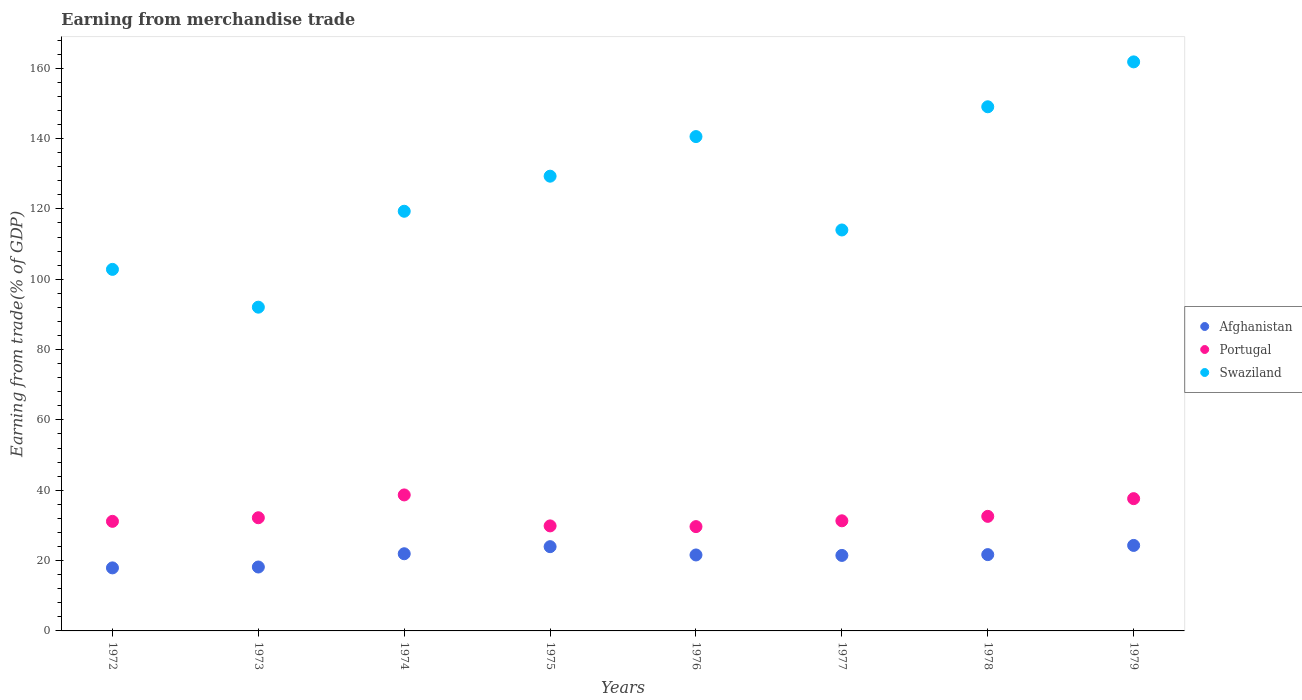What is the earnings from trade in Swaziland in 1978?
Your answer should be compact. 149.03. Across all years, what is the maximum earnings from trade in Swaziland?
Provide a short and direct response. 161.8. Across all years, what is the minimum earnings from trade in Afghanistan?
Provide a succinct answer. 17.92. In which year was the earnings from trade in Portugal maximum?
Ensure brevity in your answer.  1974. In which year was the earnings from trade in Afghanistan minimum?
Keep it short and to the point. 1972. What is the total earnings from trade in Afghanistan in the graph?
Your response must be concise. 171.07. What is the difference between the earnings from trade in Afghanistan in 1978 and that in 1979?
Ensure brevity in your answer.  -2.61. What is the difference between the earnings from trade in Swaziland in 1979 and the earnings from trade in Portugal in 1974?
Offer a terse response. 123.13. What is the average earnings from trade in Portugal per year?
Keep it short and to the point. 32.88. In the year 1979, what is the difference between the earnings from trade in Swaziland and earnings from trade in Afghanistan?
Your answer should be very brief. 137.49. In how many years, is the earnings from trade in Portugal greater than 16 %?
Provide a short and direct response. 8. What is the ratio of the earnings from trade in Portugal in 1973 to that in 1979?
Give a very brief answer. 0.86. Is the difference between the earnings from trade in Swaziland in 1973 and 1977 greater than the difference between the earnings from trade in Afghanistan in 1973 and 1977?
Keep it short and to the point. No. What is the difference between the highest and the second highest earnings from trade in Portugal?
Offer a terse response. 1.06. What is the difference between the highest and the lowest earnings from trade in Portugal?
Provide a succinct answer. 9.01. In how many years, is the earnings from trade in Swaziland greater than the average earnings from trade in Swaziland taken over all years?
Provide a short and direct response. 4. Is it the case that in every year, the sum of the earnings from trade in Portugal and earnings from trade in Swaziland  is greater than the earnings from trade in Afghanistan?
Make the answer very short. Yes. Is the earnings from trade in Afghanistan strictly greater than the earnings from trade in Swaziland over the years?
Your response must be concise. No. Is the earnings from trade in Portugal strictly less than the earnings from trade in Afghanistan over the years?
Make the answer very short. No. How many dotlines are there?
Your response must be concise. 3. How many years are there in the graph?
Provide a succinct answer. 8. What is the difference between two consecutive major ticks on the Y-axis?
Offer a terse response. 20. Are the values on the major ticks of Y-axis written in scientific E-notation?
Keep it short and to the point. No. Does the graph contain any zero values?
Offer a terse response. No. Does the graph contain grids?
Make the answer very short. No. Where does the legend appear in the graph?
Give a very brief answer. Center right. How many legend labels are there?
Keep it short and to the point. 3. What is the title of the graph?
Keep it short and to the point. Earning from merchandise trade. What is the label or title of the X-axis?
Provide a short and direct response. Years. What is the label or title of the Y-axis?
Your answer should be compact. Earning from trade(% of GDP). What is the Earning from trade(% of GDP) in Afghanistan in 1972?
Your answer should be very brief. 17.92. What is the Earning from trade(% of GDP) of Portugal in 1972?
Provide a short and direct response. 31.16. What is the Earning from trade(% of GDP) in Swaziland in 1972?
Give a very brief answer. 102.8. What is the Earning from trade(% of GDP) of Afghanistan in 1973?
Offer a very short reply. 18.17. What is the Earning from trade(% of GDP) of Portugal in 1973?
Keep it short and to the point. 32.18. What is the Earning from trade(% of GDP) of Swaziland in 1973?
Keep it short and to the point. 92.05. What is the Earning from trade(% of GDP) of Afghanistan in 1974?
Make the answer very short. 21.94. What is the Earning from trade(% of GDP) in Portugal in 1974?
Your response must be concise. 38.67. What is the Earning from trade(% of GDP) of Swaziland in 1974?
Provide a succinct answer. 119.33. What is the Earning from trade(% of GDP) of Afghanistan in 1975?
Keep it short and to the point. 23.96. What is the Earning from trade(% of GDP) in Portugal in 1975?
Your answer should be very brief. 29.86. What is the Earning from trade(% of GDP) in Swaziland in 1975?
Provide a short and direct response. 129.3. What is the Earning from trade(% of GDP) in Afghanistan in 1976?
Your response must be concise. 21.6. What is the Earning from trade(% of GDP) in Portugal in 1976?
Offer a very short reply. 29.66. What is the Earning from trade(% of GDP) in Swaziland in 1976?
Your response must be concise. 140.56. What is the Earning from trade(% of GDP) of Afghanistan in 1977?
Provide a short and direct response. 21.47. What is the Earning from trade(% of GDP) of Portugal in 1977?
Your response must be concise. 31.31. What is the Earning from trade(% of GDP) in Swaziland in 1977?
Ensure brevity in your answer.  114.01. What is the Earning from trade(% of GDP) of Afghanistan in 1978?
Offer a terse response. 21.7. What is the Earning from trade(% of GDP) of Portugal in 1978?
Offer a terse response. 32.57. What is the Earning from trade(% of GDP) of Swaziland in 1978?
Your answer should be compact. 149.03. What is the Earning from trade(% of GDP) in Afghanistan in 1979?
Give a very brief answer. 24.31. What is the Earning from trade(% of GDP) in Portugal in 1979?
Keep it short and to the point. 37.61. What is the Earning from trade(% of GDP) of Swaziland in 1979?
Offer a very short reply. 161.8. Across all years, what is the maximum Earning from trade(% of GDP) in Afghanistan?
Your answer should be compact. 24.31. Across all years, what is the maximum Earning from trade(% of GDP) of Portugal?
Your answer should be very brief. 38.67. Across all years, what is the maximum Earning from trade(% of GDP) in Swaziland?
Provide a succinct answer. 161.8. Across all years, what is the minimum Earning from trade(% of GDP) in Afghanistan?
Keep it short and to the point. 17.92. Across all years, what is the minimum Earning from trade(% of GDP) of Portugal?
Provide a short and direct response. 29.66. Across all years, what is the minimum Earning from trade(% of GDP) in Swaziland?
Ensure brevity in your answer.  92.05. What is the total Earning from trade(% of GDP) in Afghanistan in the graph?
Make the answer very short. 171.07. What is the total Earning from trade(% of GDP) in Portugal in the graph?
Offer a terse response. 263.02. What is the total Earning from trade(% of GDP) in Swaziland in the graph?
Provide a succinct answer. 1008.89. What is the difference between the Earning from trade(% of GDP) of Afghanistan in 1972 and that in 1973?
Keep it short and to the point. -0.25. What is the difference between the Earning from trade(% of GDP) of Portugal in 1972 and that in 1973?
Provide a short and direct response. -1.02. What is the difference between the Earning from trade(% of GDP) of Swaziland in 1972 and that in 1973?
Provide a short and direct response. 10.75. What is the difference between the Earning from trade(% of GDP) of Afghanistan in 1972 and that in 1974?
Ensure brevity in your answer.  -4.02. What is the difference between the Earning from trade(% of GDP) in Portugal in 1972 and that in 1974?
Keep it short and to the point. -7.51. What is the difference between the Earning from trade(% of GDP) in Swaziland in 1972 and that in 1974?
Your answer should be compact. -16.52. What is the difference between the Earning from trade(% of GDP) of Afghanistan in 1972 and that in 1975?
Ensure brevity in your answer.  -6.03. What is the difference between the Earning from trade(% of GDP) in Portugal in 1972 and that in 1975?
Offer a very short reply. 1.3. What is the difference between the Earning from trade(% of GDP) in Swaziland in 1972 and that in 1975?
Keep it short and to the point. -26.5. What is the difference between the Earning from trade(% of GDP) in Afghanistan in 1972 and that in 1976?
Give a very brief answer. -3.68. What is the difference between the Earning from trade(% of GDP) in Portugal in 1972 and that in 1976?
Offer a very short reply. 1.5. What is the difference between the Earning from trade(% of GDP) in Swaziland in 1972 and that in 1976?
Ensure brevity in your answer.  -37.76. What is the difference between the Earning from trade(% of GDP) of Afghanistan in 1972 and that in 1977?
Make the answer very short. -3.54. What is the difference between the Earning from trade(% of GDP) of Portugal in 1972 and that in 1977?
Your answer should be very brief. -0.15. What is the difference between the Earning from trade(% of GDP) of Swaziland in 1972 and that in 1977?
Your answer should be compact. -11.2. What is the difference between the Earning from trade(% of GDP) of Afghanistan in 1972 and that in 1978?
Your response must be concise. -3.77. What is the difference between the Earning from trade(% of GDP) of Portugal in 1972 and that in 1978?
Ensure brevity in your answer.  -1.42. What is the difference between the Earning from trade(% of GDP) of Swaziland in 1972 and that in 1978?
Your answer should be very brief. -46.23. What is the difference between the Earning from trade(% of GDP) in Afghanistan in 1972 and that in 1979?
Your response must be concise. -6.39. What is the difference between the Earning from trade(% of GDP) of Portugal in 1972 and that in 1979?
Provide a short and direct response. -6.45. What is the difference between the Earning from trade(% of GDP) in Swaziland in 1972 and that in 1979?
Provide a short and direct response. -59. What is the difference between the Earning from trade(% of GDP) in Afghanistan in 1973 and that in 1974?
Your response must be concise. -3.77. What is the difference between the Earning from trade(% of GDP) in Portugal in 1973 and that in 1974?
Provide a short and direct response. -6.49. What is the difference between the Earning from trade(% of GDP) of Swaziland in 1973 and that in 1974?
Provide a short and direct response. -27.27. What is the difference between the Earning from trade(% of GDP) in Afghanistan in 1973 and that in 1975?
Keep it short and to the point. -5.78. What is the difference between the Earning from trade(% of GDP) of Portugal in 1973 and that in 1975?
Your response must be concise. 2.32. What is the difference between the Earning from trade(% of GDP) in Swaziland in 1973 and that in 1975?
Your answer should be compact. -37.25. What is the difference between the Earning from trade(% of GDP) in Afghanistan in 1973 and that in 1976?
Offer a terse response. -3.43. What is the difference between the Earning from trade(% of GDP) in Portugal in 1973 and that in 1976?
Provide a succinct answer. 2.52. What is the difference between the Earning from trade(% of GDP) of Swaziland in 1973 and that in 1976?
Provide a short and direct response. -48.51. What is the difference between the Earning from trade(% of GDP) in Afghanistan in 1973 and that in 1977?
Provide a succinct answer. -3.29. What is the difference between the Earning from trade(% of GDP) of Portugal in 1973 and that in 1977?
Your response must be concise. 0.87. What is the difference between the Earning from trade(% of GDP) in Swaziland in 1973 and that in 1977?
Offer a very short reply. -21.95. What is the difference between the Earning from trade(% of GDP) of Afghanistan in 1973 and that in 1978?
Provide a short and direct response. -3.52. What is the difference between the Earning from trade(% of GDP) of Portugal in 1973 and that in 1978?
Your answer should be compact. -0.4. What is the difference between the Earning from trade(% of GDP) of Swaziland in 1973 and that in 1978?
Ensure brevity in your answer.  -56.98. What is the difference between the Earning from trade(% of GDP) in Afghanistan in 1973 and that in 1979?
Your response must be concise. -6.14. What is the difference between the Earning from trade(% of GDP) of Portugal in 1973 and that in 1979?
Your answer should be very brief. -5.43. What is the difference between the Earning from trade(% of GDP) in Swaziland in 1973 and that in 1979?
Provide a short and direct response. -69.75. What is the difference between the Earning from trade(% of GDP) of Afghanistan in 1974 and that in 1975?
Make the answer very short. -2.01. What is the difference between the Earning from trade(% of GDP) of Portugal in 1974 and that in 1975?
Keep it short and to the point. 8.81. What is the difference between the Earning from trade(% of GDP) of Swaziland in 1974 and that in 1975?
Offer a terse response. -9.97. What is the difference between the Earning from trade(% of GDP) in Afghanistan in 1974 and that in 1976?
Ensure brevity in your answer.  0.34. What is the difference between the Earning from trade(% of GDP) in Portugal in 1974 and that in 1976?
Make the answer very short. 9.01. What is the difference between the Earning from trade(% of GDP) of Swaziland in 1974 and that in 1976?
Your answer should be compact. -21.23. What is the difference between the Earning from trade(% of GDP) of Afghanistan in 1974 and that in 1977?
Provide a succinct answer. 0.48. What is the difference between the Earning from trade(% of GDP) of Portugal in 1974 and that in 1977?
Your response must be concise. 7.36. What is the difference between the Earning from trade(% of GDP) in Swaziland in 1974 and that in 1977?
Provide a succinct answer. 5.32. What is the difference between the Earning from trade(% of GDP) of Afghanistan in 1974 and that in 1978?
Give a very brief answer. 0.25. What is the difference between the Earning from trade(% of GDP) in Portugal in 1974 and that in 1978?
Offer a very short reply. 6.09. What is the difference between the Earning from trade(% of GDP) in Swaziland in 1974 and that in 1978?
Ensure brevity in your answer.  -29.71. What is the difference between the Earning from trade(% of GDP) of Afghanistan in 1974 and that in 1979?
Give a very brief answer. -2.37. What is the difference between the Earning from trade(% of GDP) of Portugal in 1974 and that in 1979?
Give a very brief answer. 1.06. What is the difference between the Earning from trade(% of GDP) of Swaziland in 1974 and that in 1979?
Your answer should be very brief. -42.48. What is the difference between the Earning from trade(% of GDP) in Afghanistan in 1975 and that in 1976?
Your response must be concise. 2.36. What is the difference between the Earning from trade(% of GDP) of Portugal in 1975 and that in 1976?
Keep it short and to the point. 0.2. What is the difference between the Earning from trade(% of GDP) in Swaziland in 1975 and that in 1976?
Provide a short and direct response. -11.26. What is the difference between the Earning from trade(% of GDP) in Afghanistan in 1975 and that in 1977?
Offer a terse response. 2.49. What is the difference between the Earning from trade(% of GDP) in Portugal in 1975 and that in 1977?
Make the answer very short. -1.45. What is the difference between the Earning from trade(% of GDP) of Swaziland in 1975 and that in 1977?
Offer a terse response. 15.3. What is the difference between the Earning from trade(% of GDP) of Afghanistan in 1975 and that in 1978?
Your answer should be compact. 2.26. What is the difference between the Earning from trade(% of GDP) of Portugal in 1975 and that in 1978?
Your response must be concise. -2.71. What is the difference between the Earning from trade(% of GDP) of Swaziland in 1975 and that in 1978?
Provide a short and direct response. -19.73. What is the difference between the Earning from trade(% of GDP) in Afghanistan in 1975 and that in 1979?
Make the answer very short. -0.35. What is the difference between the Earning from trade(% of GDP) of Portugal in 1975 and that in 1979?
Offer a terse response. -7.75. What is the difference between the Earning from trade(% of GDP) in Swaziland in 1975 and that in 1979?
Your response must be concise. -32.5. What is the difference between the Earning from trade(% of GDP) in Afghanistan in 1976 and that in 1977?
Offer a very short reply. 0.13. What is the difference between the Earning from trade(% of GDP) of Portugal in 1976 and that in 1977?
Your answer should be compact. -1.65. What is the difference between the Earning from trade(% of GDP) of Swaziland in 1976 and that in 1977?
Provide a short and direct response. 26.56. What is the difference between the Earning from trade(% of GDP) in Afghanistan in 1976 and that in 1978?
Your answer should be very brief. -0.1. What is the difference between the Earning from trade(% of GDP) in Portugal in 1976 and that in 1978?
Provide a short and direct response. -2.92. What is the difference between the Earning from trade(% of GDP) in Swaziland in 1976 and that in 1978?
Provide a short and direct response. -8.47. What is the difference between the Earning from trade(% of GDP) in Afghanistan in 1976 and that in 1979?
Make the answer very short. -2.71. What is the difference between the Earning from trade(% of GDP) in Portugal in 1976 and that in 1979?
Provide a short and direct response. -7.95. What is the difference between the Earning from trade(% of GDP) in Swaziland in 1976 and that in 1979?
Give a very brief answer. -21.24. What is the difference between the Earning from trade(% of GDP) of Afghanistan in 1977 and that in 1978?
Ensure brevity in your answer.  -0.23. What is the difference between the Earning from trade(% of GDP) in Portugal in 1977 and that in 1978?
Provide a short and direct response. -1.26. What is the difference between the Earning from trade(% of GDP) in Swaziland in 1977 and that in 1978?
Provide a short and direct response. -35.03. What is the difference between the Earning from trade(% of GDP) in Afghanistan in 1977 and that in 1979?
Your answer should be compact. -2.84. What is the difference between the Earning from trade(% of GDP) of Portugal in 1977 and that in 1979?
Your answer should be compact. -6.3. What is the difference between the Earning from trade(% of GDP) in Swaziland in 1977 and that in 1979?
Your answer should be compact. -47.8. What is the difference between the Earning from trade(% of GDP) in Afghanistan in 1978 and that in 1979?
Offer a terse response. -2.61. What is the difference between the Earning from trade(% of GDP) of Portugal in 1978 and that in 1979?
Your response must be concise. -5.04. What is the difference between the Earning from trade(% of GDP) in Swaziland in 1978 and that in 1979?
Provide a short and direct response. -12.77. What is the difference between the Earning from trade(% of GDP) in Afghanistan in 1972 and the Earning from trade(% of GDP) in Portugal in 1973?
Your response must be concise. -14.25. What is the difference between the Earning from trade(% of GDP) of Afghanistan in 1972 and the Earning from trade(% of GDP) of Swaziland in 1973?
Make the answer very short. -74.13. What is the difference between the Earning from trade(% of GDP) of Portugal in 1972 and the Earning from trade(% of GDP) of Swaziland in 1973?
Offer a very short reply. -60.9. What is the difference between the Earning from trade(% of GDP) in Afghanistan in 1972 and the Earning from trade(% of GDP) in Portugal in 1974?
Ensure brevity in your answer.  -20.74. What is the difference between the Earning from trade(% of GDP) in Afghanistan in 1972 and the Earning from trade(% of GDP) in Swaziland in 1974?
Provide a succinct answer. -101.4. What is the difference between the Earning from trade(% of GDP) in Portugal in 1972 and the Earning from trade(% of GDP) in Swaziland in 1974?
Give a very brief answer. -88.17. What is the difference between the Earning from trade(% of GDP) in Afghanistan in 1972 and the Earning from trade(% of GDP) in Portugal in 1975?
Provide a short and direct response. -11.94. What is the difference between the Earning from trade(% of GDP) of Afghanistan in 1972 and the Earning from trade(% of GDP) of Swaziland in 1975?
Your answer should be compact. -111.38. What is the difference between the Earning from trade(% of GDP) of Portugal in 1972 and the Earning from trade(% of GDP) of Swaziland in 1975?
Your response must be concise. -98.14. What is the difference between the Earning from trade(% of GDP) in Afghanistan in 1972 and the Earning from trade(% of GDP) in Portugal in 1976?
Offer a terse response. -11.73. What is the difference between the Earning from trade(% of GDP) of Afghanistan in 1972 and the Earning from trade(% of GDP) of Swaziland in 1976?
Provide a short and direct response. -122.64. What is the difference between the Earning from trade(% of GDP) in Portugal in 1972 and the Earning from trade(% of GDP) in Swaziland in 1976?
Give a very brief answer. -109.4. What is the difference between the Earning from trade(% of GDP) in Afghanistan in 1972 and the Earning from trade(% of GDP) in Portugal in 1977?
Offer a very short reply. -13.39. What is the difference between the Earning from trade(% of GDP) of Afghanistan in 1972 and the Earning from trade(% of GDP) of Swaziland in 1977?
Give a very brief answer. -96.08. What is the difference between the Earning from trade(% of GDP) in Portugal in 1972 and the Earning from trade(% of GDP) in Swaziland in 1977?
Offer a terse response. -82.85. What is the difference between the Earning from trade(% of GDP) in Afghanistan in 1972 and the Earning from trade(% of GDP) in Portugal in 1978?
Provide a succinct answer. -14.65. What is the difference between the Earning from trade(% of GDP) in Afghanistan in 1972 and the Earning from trade(% of GDP) in Swaziland in 1978?
Your answer should be compact. -131.11. What is the difference between the Earning from trade(% of GDP) of Portugal in 1972 and the Earning from trade(% of GDP) of Swaziland in 1978?
Offer a terse response. -117.88. What is the difference between the Earning from trade(% of GDP) of Afghanistan in 1972 and the Earning from trade(% of GDP) of Portugal in 1979?
Your response must be concise. -19.68. What is the difference between the Earning from trade(% of GDP) in Afghanistan in 1972 and the Earning from trade(% of GDP) in Swaziland in 1979?
Make the answer very short. -143.88. What is the difference between the Earning from trade(% of GDP) of Portugal in 1972 and the Earning from trade(% of GDP) of Swaziland in 1979?
Your answer should be compact. -130.65. What is the difference between the Earning from trade(% of GDP) in Afghanistan in 1973 and the Earning from trade(% of GDP) in Portugal in 1974?
Keep it short and to the point. -20.5. What is the difference between the Earning from trade(% of GDP) in Afghanistan in 1973 and the Earning from trade(% of GDP) in Swaziland in 1974?
Provide a succinct answer. -101.15. What is the difference between the Earning from trade(% of GDP) in Portugal in 1973 and the Earning from trade(% of GDP) in Swaziland in 1974?
Your answer should be very brief. -87.15. What is the difference between the Earning from trade(% of GDP) in Afghanistan in 1973 and the Earning from trade(% of GDP) in Portugal in 1975?
Give a very brief answer. -11.69. What is the difference between the Earning from trade(% of GDP) of Afghanistan in 1973 and the Earning from trade(% of GDP) of Swaziland in 1975?
Your answer should be very brief. -111.13. What is the difference between the Earning from trade(% of GDP) in Portugal in 1973 and the Earning from trade(% of GDP) in Swaziland in 1975?
Give a very brief answer. -97.12. What is the difference between the Earning from trade(% of GDP) of Afghanistan in 1973 and the Earning from trade(% of GDP) of Portugal in 1976?
Provide a short and direct response. -11.49. What is the difference between the Earning from trade(% of GDP) of Afghanistan in 1973 and the Earning from trade(% of GDP) of Swaziland in 1976?
Offer a very short reply. -122.39. What is the difference between the Earning from trade(% of GDP) of Portugal in 1973 and the Earning from trade(% of GDP) of Swaziland in 1976?
Provide a short and direct response. -108.38. What is the difference between the Earning from trade(% of GDP) in Afghanistan in 1973 and the Earning from trade(% of GDP) in Portugal in 1977?
Your answer should be compact. -13.14. What is the difference between the Earning from trade(% of GDP) in Afghanistan in 1973 and the Earning from trade(% of GDP) in Swaziland in 1977?
Ensure brevity in your answer.  -95.83. What is the difference between the Earning from trade(% of GDP) of Portugal in 1973 and the Earning from trade(% of GDP) of Swaziland in 1977?
Your answer should be compact. -81.83. What is the difference between the Earning from trade(% of GDP) of Afghanistan in 1973 and the Earning from trade(% of GDP) of Portugal in 1978?
Provide a succinct answer. -14.4. What is the difference between the Earning from trade(% of GDP) of Afghanistan in 1973 and the Earning from trade(% of GDP) of Swaziland in 1978?
Your answer should be very brief. -130.86. What is the difference between the Earning from trade(% of GDP) in Portugal in 1973 and the Earning from trade(% of GDP) in Swaziland in 1978?
Offer a terse response. -116.86. What is the difference between the Earning from trade(% of GDP) in Afghanistan in 1973 and the Earning from trade(% of GDP) in Portugal in 1979?
Provide a short and direct response. -19.44. What is the difference between the Earning from trade(% of GDP) of Afghanistan in 1973 and the Earning from trade(% of GDP) of Swaziland in 1979?
Your answer should be compact. -143.63. What is the difference between the Earning from trade(% of GDP) of Portugal in 1973 and the Earning from trade(% of GDP) of Swaziland in 1979?
Keep it short and to the point. -129.62. What is the difference between the Earning from trade(% of GDP) in Afghanistan in 1974 and the Earning from trade(% of GDP) in Portugal in 1975?
Make the answer very short. -7.92. What is the difference between the Earning from trade(% of GDP) of Afghanistan in 1974 and the Earning from trade(% of GDP) of Swaziland in 1975?
Your response must be concise. -107.36. What is the difference between the Earning from trade(% of GDP) in Portugal in 1974 and the Earning from trade(% of GDP) in Swaziland in 1975?
Offer a very short reply. -90.63. What is the difference between the Earning from trade(% of GDP) in Afghanistan in 1974 and the Earning from trade(% of GDP) in Portugal in 1976?
Your response must be concise. -7.72. What is the difference between the Earning from trade(% of GDP) of Afghanistan in 1974 and the Earning from trade(% of GDP) of Swaziland in 1976?
Ensure brevity in your answer.  -118.62. What is the difference between the Earning from trade(% of GDP) in Portugal in 1974 and the Earning from trade(% of GDP) in Swaziland in 1976?
Keep it short and to the point. -101.89. What is the difference between the Earning from trade(% of GDP) in Afghanistan in 1974 and the Earning from trade(% of GDP) in Portugal in 1977?
Ensure brevity in your answer.  -9.37. What is the difference between the Earning from trade(% of GDP) in Afghanistan in 1974 and the Earning from trade(% of GDP) in Swaziland in 1977?
Offer a terse response. -92.06. What is the difference between the Earning from trade(% of GDP) in Portugal in 1974 and the Earning from trade(% of GDP) in Swaziland in 1977?
Give a very brief answer. -75.34. What is the difference between the Earning from trade(% of GDP) in Afghanistan in 1974 and the Earning from trade(% of GDP) in Portugal in 1978?
Offer a terse response. -10.63. What is the difference between the Earning from trade(% of GDP) in Afghanistan in 1974 and the Earning from trade(% of GDP) in Swaziland in 1978?
Your answer should be compact. -127.09. What is the difference between the Earning from trade(% of GDP) of Portugal in 1974 and the Earning from trade(% of GDP) of Swaziland in 1978?
Ensure brevity in your answer.  -110.37. What is the difference between the Earning from trade(% of GDP) of Afghanistan in 1974 and the Earning from trade(% of GDP) of Portugal in 1979?
Your response must be concise. -15.67. What is the difference between the Earning from trade(% of GDP) of Afghanistan in 1974 and the Earning from trade(% of GDP) of Swaziland in 1979?
Offer a very short reply. -139.86. What is the difference between the Earning from trade(% of GDP) in Portugal in 1974 and the Earning from trade(% of GDP) in Swaziland in 1979?
Provide a short and direct response. -123.13. What is the difference between the Earning from trade(% of GDP) of Afghanistan in 1975 and the Earning from trade(% of GDP) of Portugal in 1976?
Offer a terse response. -5.7. What is the difference between the Earning from trade(% of GDP) of Afghanistan in 1975 and the Earning from trade(% of GDP) of Swaziland in 1976?
Offer a very short reply. -116.6. What is the difference between the Earning from trade(% of GDP) in Portugal in 1975 and the Earning from trade(% of GDP) in Swaziland in 1976?
Your answer should be compact. -110.7. What is the difference between the Earning from trade(% of GDP) of Afghanistan in 1975 and the Earning from trade(% of GDP) of Portugal in 1977?
Keep it short and to the point. -7.35. What is the difference between the Earning from trade(% of GDP) in Afghanistan in 1975 and the Earning from trade(% of GDP) in Swaziland in 1977?
Your response must be concise. -90.05. What is the difference between the Earning from trade(% of GDP) of Portugal in 1975 and the Earning from trade(% of GDP) of Swaziland in 1977?
Keep it short and to the point. -84.14. What is the difference between the Earning from trade(% of GDP) in Afghanistan in 1975 and the Earning from trade(% of GDP) in Portugal in 1978?
Make the answer very short. -8.62. What is the difference between the Earning from trade(% of GDP) in Afghanistan in 1975 and the Earning from trade(% of GDP) in Swaziland in 1978?
Provide a succinct answer. -125.08. What is the difference between the Earning from trade(% of GDP) of Portugal in 1975 and the Earning from trade(% of GDP) of Swaziland in 1978?
Make the answer very short. -119.17. What is the difference between the Earning from trade(% of GDP) of Afghanistan in 1975 and the Earning from trade(% of GDP) of Portugal in 1979?
Ensure brevity in your answer.  -13.65. What is the difference between the Earning from trade(% of GDP) of Afghanistan in 1975 and the Earning from trade(% of GDP) of Swaziland in 1979?
Make the answer very short. -137.84. What is the difference between the Earning from trade(% of GDP) in Portugal in 1975 and the Earning from trade(% of GDP) in Swaziland in 1979?
Ensure brevity in your answer.  -131.94. What is the difference between the Earning from trade(% of GDP) of Afghanistan in 1976 and the Earning from trade(% of GDP) of Portugal in 1977?
Ensure brevity in your answer.  -9.71. What is the difference between the Earning from trade(% of GDP) of Afghanistan in 1976 and the Earning from trade(% of GDP) of Swaziland in 1977?
Provide a succinct answer. -92.41. What is the difference between the Earning from trade(% of GDP) in Portugal in 1976 and the Earning from trade(% of GDP) in Swaziland in 1977?
Make the answer very short. -84.35. What is the difference between the Earning from trade(% of GDP) in Afghanistan in 1976 and the Earning from trade(% of GDP) in Portugal in 1978?
Your response must be concise. -10.97. What is the difference between the Earning from trade(% of GDP) of Afghanistan in 1976 and the Earning from trade(% of GDP) of Swaziland in 1978?
Offer a very short reply. -127.43. What is the difference between the Earning from trade(% of GDP) of Portugal in 1976 and the Earning from trade(% of GDP) of Swaziland in 1978?
Provide a short and direct response. -119.38. What is the difference between the Earning from trade(% of GDP) in Afghanistan in 1976 and the Earning from trade(% of GDP) in Portugal in 1979?
Offer a terse response. -16.01. What is the difference between the Earning from trade(% of GDP) in Afghanistan in 1976 and the Earning from trade(% of GDP) in Swaziland in 1979?
Ensure brevity in your answer.  -140.2. What is the difference between the Earning from trade(% of GDP) in Portugal in 1976 and the Earning from trade(% of GDP) in Swaziland in 1979?
Offer a very short reply. -132.14. What is the difference between the Earning from trade(% of GDP) in Afghanistan in 1977 and the Earning from trade(% of GDP) in Portugal in 1978?
Your response must be concise. -11.11. What is the difference between the Earning from trade(% of GDP) of Afghanistan in 1977 and the Earning from trade(% of GDP) of Swaziland in 1978?
Ensure brevity in your answer.  -127.57. What is the difference between the Earning from trade(% of GDP) in Portugal in 1977 and the Earning from trade(% of GDP) in Swaziland in 1978?
Provide a short and direct response. -117.72. What is the difference between the Earning from trade(% of GDP) in Afghanistan in 1977 and the Earning from trade(% of GDP) in Portugal in 1979?
Your answer should be very brief. -16.14. What is the difference between the Earning from trade(% of GDP) in Afghanistan in 1977 and the Earning from trade(% of GDP) in Swaziland in 1979?
Keep it short and to the point. -140.34. What is the difference between the Earning from trade(% of GDP) in Portugal in 1977 and the Earning from trade(% of GDP) in Swaziland in 1979?
Give a very brief answer. -130.49. What is the difference between the Earning from trade(% of GDP) of Afghanistan in 1978 and the Earning from trade(% of GDP) of Portugal in 1979?
Provide a short and direct response. -15.91. What is the difference between the Earning from trade(% of GDP) in Afghanistan in 1978 and the Earning from trade(% of GDP) in Swaziland in 1979?
Give a very brief answer. -140.11. What is the difference between the Earning from trade(% of GDP) of Portugal in 1978 and the Earning from trade(% of GDP) of Swaziland in 1979?
Make the answer very short. -129.23. What is the average Earning from trade(% of GDP) in Afghanistan per year?
Your response must be concise. 21.38. What is the average Earning from trade(% of GDP) in Portugal per year?
Offer a very short reply. 32.88. What is the average Earning from trade(% of GDP) in Swaziland per year?
Your response must be concise. 126.11. In the year 1972, what is the difference between the Earning from trade(% of GDP) of Afghanistan and Earning from trade(% of GDP) of Portugal?
Give a very brief answer. -13.23. In the year 1972, what is the difference between the Earning from trade(% of GDP) in Afghanistan and Earning from trade(% of GDP) in Swaziland?
Ensure brevity in your answer.  -84.88. In the year 1972, what is the difference between the Earning from trade(% of GDP) of Portugal and Earning from trade(% of GDP) of Swaziland?
Offer a very short reply. -71.64. In the year 1973, what is the difference between the Earning from trade(% of GDP) in Afghanistan and Earning from trade(% of GDP) in Portugal?
Offer a very short reply. -14.01. In the year 1973, what is the difference between the Earning from trade(% of GDP) of Afghanistan and Earning from trade(% of GDP) of Swaziland?
Offer a terse response. -73.88. In the year 1973, what is the difference between the Earning from trade(% of GDP) of Portugal and Earning from trade(% of GDP) of Swaziland?
Offer a terse response. -59.88. In the year 1974, what is the difference between the Earning from trade(% of GDP) in Afghanistan and Earning from trade(% of GDP) in Portugal?
Keep it short and to the point. -16.73. In the year 1974, what is the difference between the Earning from trade(% of GDP) in Afghanistan and Earning from trade(% of GDP) in Swaziland?
Give a very brief answer. -97.38. In the year 1974, what is the difference between the Earning from trade(% of GDP) of Portugal and Earning from trade(% of GDP) of Swaziland?
Ensure brevity in your answer.  -80.66. In the year 1975, what is the difference between the Earning from trade(% of GDP) in Afghanistan and Earning from trade(% of GDP) in Portugal?
Ensure brevity in your answer.  -5.9. In the year 1975, what is the difference between the Earning from trade(% of GDP) of Afghanistan and Earning from trade(% of GDP) of Swaziland?
Your response must be concise. -105.34. In the year 1975, what is the difference between the Earning from trade(% of GDP) of Portugal and Earning from trade(% of GDP) of Swaziland?
Provide a short and direct response. -99.44. In the year 1976, what is the difference between the Earning from trade(% of GDP) of Afghanistan and Earning from trade(% of GDP) of Portugal?
Provide a short and direct response. -8.06. In the year 1976, what is the difference between the Earning from trade(% of GDP) of Afghanistan and Earning from trade(% of GDP) of Swaziland?
Give a very brief answer. -118.96. In the year 1976, what is the difference between the Earning from trade(% of GDP) in Portugal and Earning from trade(% of GDP) in Swaziland?
Offer a very short reply. -110.9. In the year 1977, what is the difference between the Earning from trade(% of GDP) of Afghanistan and Earning from trade(% of GDP) of Portugal?
Provide a succinct answer. -9.84. In the year 1977, what is the difference between the Earning from trade(% of GDP) in Afghanistan and Earning from trade(% of GDP) in Swaziland?
Ensure brevity in your answer.  -92.54. In the year 1977, what is the difference between the Earning from trade(% of GDP) of Portugal and Earning from trade(% of GDP) of Swaziland?
Keep it short and to the point. -82.69. In the year 1978, what is the difference between the Earning from trade(% of GDP) of Afghanistan and Earning from trade(% of GDP) of Portugal?
Make the answer very short. -10.88. In the year 1978, what is the difference between the Earning from trade(% of GDP) in Afghanistan and Earning from trade(% of GDP) in Swaziland?
Offer a very short reply. -127.34. In the year 1978, what is the difference between the Earning from trade(% of GDP) of Portugal and Earning from trade(% of GDP) of Swaziland?
Offer a very short reply. -116.46. In the year 1979, what is the difference between the Earning from trade(% of GDP) in Afghanistan and Earning from trade(% of GDP) in Portugal?
Offer a very short reply. -13.3. In the year 1979, what is the difference between the Earning from trade(% of GDP) in Afghanistan and Earning from trade(% of GDP) in Swaziland?
Provide a succinct answer. -137.49. In the year 1979, what is the difference between the Earning from trade(% of GDP) of Portugal and Earning from trade(% of GDP) of Swaziland?
Your answer should be very brief. -124.19. What is the ratio of the Earning from trade(% of GDP) of Afghanistan in 1972 to that in 1973?
Give a very brief answer. 0.99. What is the ratio of the Earning from trade(% of GDP) of Portugal in 1972 to that in 1973?
Make the answer very short. 0.97. What is the ratio of the Earning from trade(% of GDP) of Swaziland in 1972 to that in 1973?
Offer a very short reply. 1.12. What is the ratio of the Earning from trade(% of GDP) of Afghanistan in 1972 to that in 1974?
Your response must be concise. 0.82. What is the ratio of the Earning from trade(% of GDP) of Portugal in 1972 to that in 1974?
Ensure brevity in your answer.  0.81. What is the ratio of the Earning from trade(% of GDP) of Swaziland in 1972 to that in 1974?
Your answer should be very brief. 0.86. What is the ratio of the Earning from trade(% of GDP) in Afghanistan in 1972 to that in 1975?
Make the answer very short. 0.75. What is the ratio of the Earning from trade(% of GDP) of Portugal in 1972 to that in 1975?
Keep it short and to the point. 1.04. What is the ratio of the Earning from trade(% of GDP) of Swaziland in 1972 to that in 1975?
Provide a succinct answer. 0.8. What is the ratio of the Earning from trade(% of GDP) in Afghanistan in 1972 to that in 1976?
Give a very brief answer. 0.83. What is the ratio of the Earning from trade(% of GDP) of Portugal in 1972 to that in 1976?
Give a very brief answer. 1.05. What is the ratio of the Earning from trade(% of GDP) of Swaziland in 1972 to that in 1976?
Keep it short and to the point. 0.73. What is the ratio of the Earning from trade(% of GDP) of Afghanistan in 1972 to that in 1977?
Make the answer very short. 0.83. What is the ratio of the Earning from trade(% of GDP) of Swaziland in 1972 to that in 1977?
Your answer should be very brief. 0.9. What is the ratio of the Earning from trade(% of GDP) in Afghanistan in 1972 to that in 1978?
Your answer should be very brief. 0.83. What is the ratio of the Earning from trade(% of GDP) of Portugal in 1972 to that in 1978?
Give a very brief answer. 0.96. What is the ratio of the Earning from trade(% of GDP) of Swaziland in 1972 to that in 1978?
Make the answer very short. 0.69. What is the ratio of the Earning from trade(% of GDP) in Afghanistan in 1972 to that in 1979?
Ensure brevity in your answer.  0.74. What is the ratio of the Earning from trade(% of GDP) of Portugal in 1972 to that in 1979?
Offer a very short reply. 0.83. What is the ratio of the Earning from trade(% of GDP) of Swaziland in 1972 to that in 1979?
Ensure brevity in your answer.  0.64. What is the ratio of the Earning from trade(% of GDP) of Afghanistan in 1973 to that in 1974?
Provide a succinct answer. 0.83. What is the ratio of the Earning from trade(% of GDP) of Portugal in 1973 to that in 1974?
Offer a terse response. 0.83. What is the ratio of the Earning from trade(% of GDP) in Swaziland in 1973 to that in 1974?
Your answer should be very brief. 0.77. What is the ratio of the Earning from trade(% of GDP) of Afghanistan in 1973 to that in 1975?
Make the answer very short. 0.76. What is the ratio of the Earning from trade(% of GDP) in Portugal in 1973 to that in 1975?
Make the answer very short. 1.08. What is the ratio of the Earning from trade(% of GDP) of Swaziland in 1973 to that in 1975?
Your answer should be compact. 0.71. What is the ratio of the Earning from trade(% of GDP) of Afghanistan in 1973 to that in 1976?
Your answer should be compact. 0.84. What is the ratio of the Earning from trade(% of GDP) in Portugal in 1973 to that in 1976?
Provide a succinct answer. 1.08. What is the ratio of the Earning from trade(% of GDP) in Swaziland in 1973 to that in 1976?
Give a very brief answer. 0.65. What is the ratio of the Earning from trade(% of GDP) in Afghanistan in 1973 to that in 1977?
Provide a short and direct response. 0.85. What is the ratio of the Earning from trade(% of GDP) of Portugal in 1973 to that in 1977?
Provide a short and direct response. 1.03. What is the ratio of the Earning from trade(% of GDP) of Swaziland in 1973 to that in 1977?
Your response must be concise. 0.81. What is the ratio of the Earning from trade(% of GDP) in Afghanistan in 1973 to that in 1978?
Give a very brief answer. 0.84. What is the ratio of the Earning from trade(% of GDP) of Portugal in 1973 to that in 1978?
Make the answer very short. 0.99. What is the ratio of the Earning from trade(% of GDP) in Swaziland in 1973 to that in 1978?
Provide a short and direct response. 0.62. What is the ratio of the Earning from trade(% of GDP) in Afghanistan in 1973 to that in 1979?
Provide a succinct answer. 0.75. What is the ratio of the Earning from trade(% of GDP) in Portugal in 1973 to that in 1979?
Provide a succinct answer. 0.86. What is the ratio of the Earning from trade(% of GDP) in Swaziland in 1973 to that in 1979?
Your response must be concise. 0.57. What is the ratio of the Earning from trade(% of GDP) of Afghanistan in 1974 to that in 1975?
Offer a very short reply. 0.92. What is the ratio of the Earning from trade(% of GDP) in Portugal in 1974 to that in 1975?
Keep it short and to the point. 1.29. What is the ratio of the Earning from trade(% of GDP) in Swaziland in 1974 to that in 1975?
Provide a succinct answer. 0.92. What is the ratio of the Earning from trade(% of GDP) in Afghanistan in 1974 to that in 1976?
Give a very brief answer. 1.02. What is the ratio of the Earning from trade(% of GDP) in Portugal in 1974 to that in 1976?
Provide a short and direct response. 1.3. What is the ratio of the Earning from trade(% of GDP) of Swaziland in 1974 to that in 1976?
Keep it short and to the point. 0.85. What is the ratio of the Earning from trade(% of GDP) of Afghanistan in 1974 to that in 1977?
Ensure brevity in your answer.  1.02. What is the ratio of the Earning from trade(% of GDP) of Portugal in 1974 to that in 1977?
Offer a very short reply. 1.24. What is the ratio of the Earning from trade(% of GDP) of Swaziland in 1974 to that in 1977?
Provide a succinct answer. 1.05. What is the ratio of the Earning from trade(% of GDP) in Afghanistan in 1974 to that in 1978?
Offer a very short reply. 1.01. What is the ratio of the Earning from trade(% of GDP) in Portugal in 1974 to that in 1978?
Your answer should be very brief. 1.19. What is the ratio of the Earning from trade(% of GDP) of Swaziland in 1974 to that in 1978?
Your answer should be compact. 0.8. What is the ratio of the Earning from trade(% of GDP) in Afghanistan in 1974 to that in 1979?
Offer a very short reply. 0.9. What is the ratio of the Earning from trade(% of GDP) of Portugal in 1974 to that in 1979?
Your response must be concise. 1.03. What is the ratio of the Earning from trade(% of GDP) of Swaziland in 1974 to that in 1979?
Your answer should be very brief. 0.74. What is the ratio of the Earning from trade(% of GDP) of Afghanistan in 1975 to that in 1976?
Offer a very short reply. 1.11. What is the ratio of the Earning from trade(% of GDP) in Portugal in 1975 to that in 1976?
Your response must be concise. 1.01. What is the ratio of the Earning from trade(% of GDP) in Swaziland in 1975 to that in 1976?
Your answer should be very brief. 0.92. What is the ratio of the Earning from trade(% of GDP) in Afghanistan in 1975 to that in 1977?
Make the answer very short. 1.12. What is the ratio of the Earning from trade(% of GDP) of Portugal in 1975 to that in 1977?
Your response must be concise. 0.95. What is the ratio of the Earning from trade(% of GDP) in Swaziland in 1975 to that in 1977?
Make the answer very short. 1.13. What is the ratio of the Earning from trade(% of GDP) in Afghanistan in 1975 to that in 1978?
Offer a terse response. 1.1. What is the ratio of the Earning from trade(% of GDP) in Swaziland in 1975 to that in 1978?
Offer a very short reply. 0.87. What is the ratio of the Earning from trade(% of GDP) in Afghanistan in 1975 to that in 1979?
Offer a very short reply. 0.99. What is the ratio of the Earning from trade(% of GDP) in Portugal in 1975 to that in 1979?
Give a very brief answer. 0.79. What is the ratio of the Earning from trade(% of GDP) in Swaziland in 1975 to that in 1979?
Ensure brevity in your answer.  0.8. What is the ratio of the Earning from trade(% of GDP) of Portugal in 1976 to that in 1977?
Ensure brevity in your answer.  0.95. What is the ratio of the Earning from trade(% of GDP) in Swaziland in 1976 to that in 1977?
Provide a short and direct response. 1.23. What is the ratio of the Earning from trade(% of GDP) of Afghanistan in 1976 to that in 1978?
Make the answer very short. 1. What is the ratio of the Earning from trade(% of GDP) of Portugal in 1976 to that in 1978?
Make the answer very short. 0.91. What is the ratio of the Earning from trade(% of GDP) of Swaziland in 1976 to that in 1978?
Your answer should be compact. 0.94. What is the ratio of the Earning from trade(% of GDP) of Afghanistan in 1976 to that in 1979?
Ensure brevity in your answer.  0.89. What is the ratio of the Earning from trade(% of GDP) in Portugal in 1976 to that in 1979?
Keep it short and to the point. 0.79. What is the ratio of the Earning from trade(% of GDP) in Swaziland in 1976 to that in 1979?
Your answer should be very brief. 0.87. What is the ratio of the Earning from trade(% of GDP) in Portugal in 1977 to that in 1978?
Provide a succinct answer. 0.96. What is the ratio of the Earning from trade(% of GDP) of Swaziland in 1977 to that in 1978?
Your response must be concise. 0.77. What is the ratio of the Earning from trade(% of GDP) of Afghanistan in 1977 to that in 1979?
Ensure brevity in your answer.  0.88. What is the ratio of the Earning from trade(% of GDP) of Portugal in 1977 to that in 1979?
Offer a terse response. 0.83. What is the ratio of the Earning from trade(% of GDP) of Swaziland in 1977 to that in 1979?
Keep it short and to the point. 0.7. What is the ratio of the Earning from trade(% of GDP) in Afghanistan in 1978 to that in 1979?
Ensure brevity in your answer.  0.89. What is the ratio of the Earning from trade(% of GDP) in Portugal in 1978 to that in 1979?
Make the answer very short. 0.87. What is the ratio of the Earning from trade(% of GDP) of Swaziland in 1978 to that in 1979?
Provide a succinct answer. 0.92. What is the difference between the highest and the second highest Earning from trade(% of GDP) in Afghanistan?
Ensure brevity in your answer.  0.35. What is the difference between the highest and the second highest Earning from trade(% of GDP) in Portugal?
Offer a very short reply. 1.06. What is the difference between the highest and the second highest Earning from trade(% of GDP) in Swaziland?
Make the answer very short. 12.77. What is the difference between the highest and the lowest Earning from trade(% of GDP) of Afghanistan?
Give a very brief answer. 6.39. What is the difference between the highest and the lowest Earning from trade(% of GDP) of Portugal?
Your response must be concise. 9.01. What is the difference between the highest and the lowest Earning from trade(% of GDP) in Swaziland?
Provide a short and direct response. 69.75. 